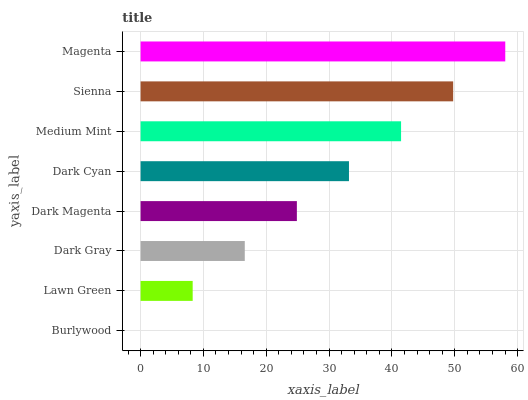Is Burlywood the minimum?
Answer yes or no. Yes. Is Magenta the maximum?
Answer yes or no. Yes. Is Lawn Green the minimum?
Answer yes or no. No. Is Lawn Green the maximum?
Answer yes or no. No. Is Lawn Green greater than Burlywood?
Answer yes or no. Yes. Is Burlywood less than Lawn Green?
Answer yes or no. Yes. Is Burlywood greater than Lawn Green?
Answer yes or no. No. Is Lawn Green less than Burlywood?
Answer yes or no. No. Is Dark Cyan the high median?
Answer yes or no. Yes. Is Dark Magenta the low median?
Answer yes or no. Yes. Is Dark Magenta the high median?
Answer yes or no. No. Is Sienna the low median?
Answer yes or no. No. 